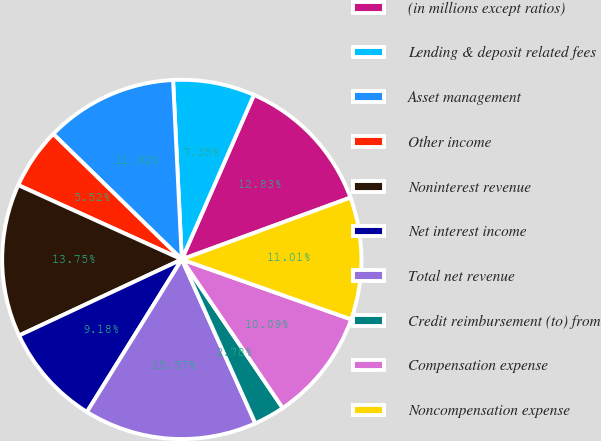Convert chart to OTSL. <chart><loc_0><loc_0><loc_500><loc_500><pie_chart><fcel>(in millions except ratios)<fcel>Lending & deposit related fees<fcel>Asset management<fcel>Other income<fcel>Noninterest revenue<fcel>Net interest income<fcel>Total net revenue<fcel>Credit reimbursement (to) from<fcel>Compensation expense<fcel>Noncompensation expense<nl><fcel>12.83%<fcel>7.35%<fcel>11.92%<fcel>5.52%<fcel>13.75%<fcel>9.18%<fcel>15.57%<fcel>2.78%<fcel>10.09%<fcel>11.01%<nl></chart> 